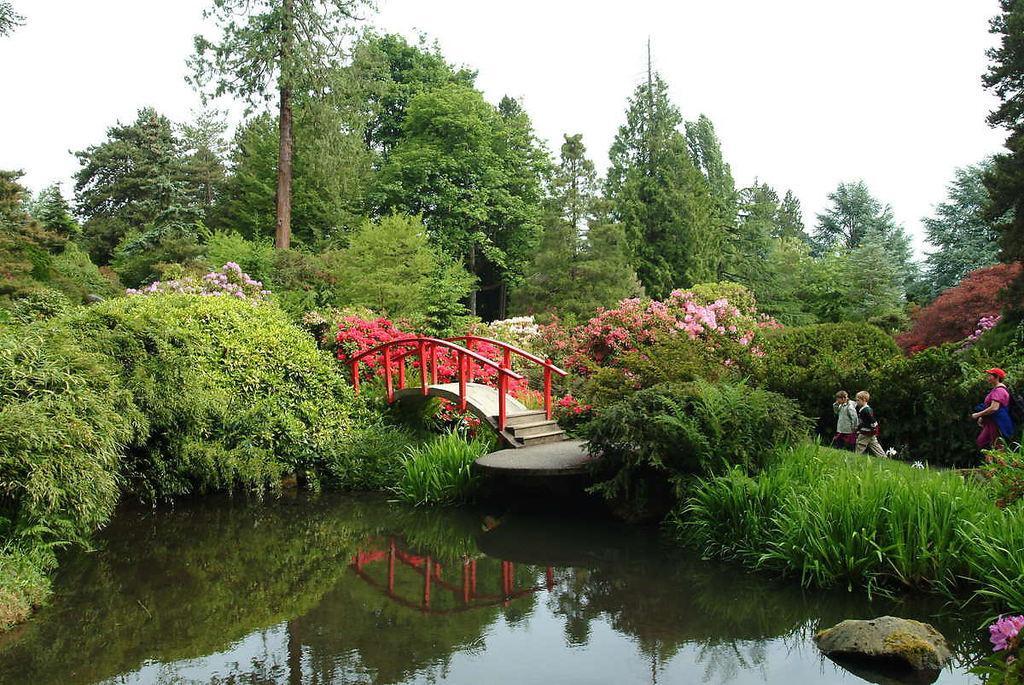Describe this image in one or two sentences. At the bottom of the picture, we see water and this water might be in the pond. On the right side, we see the grass, stone and plants. On the right side, we see three people are walking. In the middle of the picture, we see the staircase and the bridge. Beside that, we see the railing. On the left side, we see the trees which have flowers. These flowers are in violet, red, white and pink color. There are trees in the background. At the top, we see the sky. 